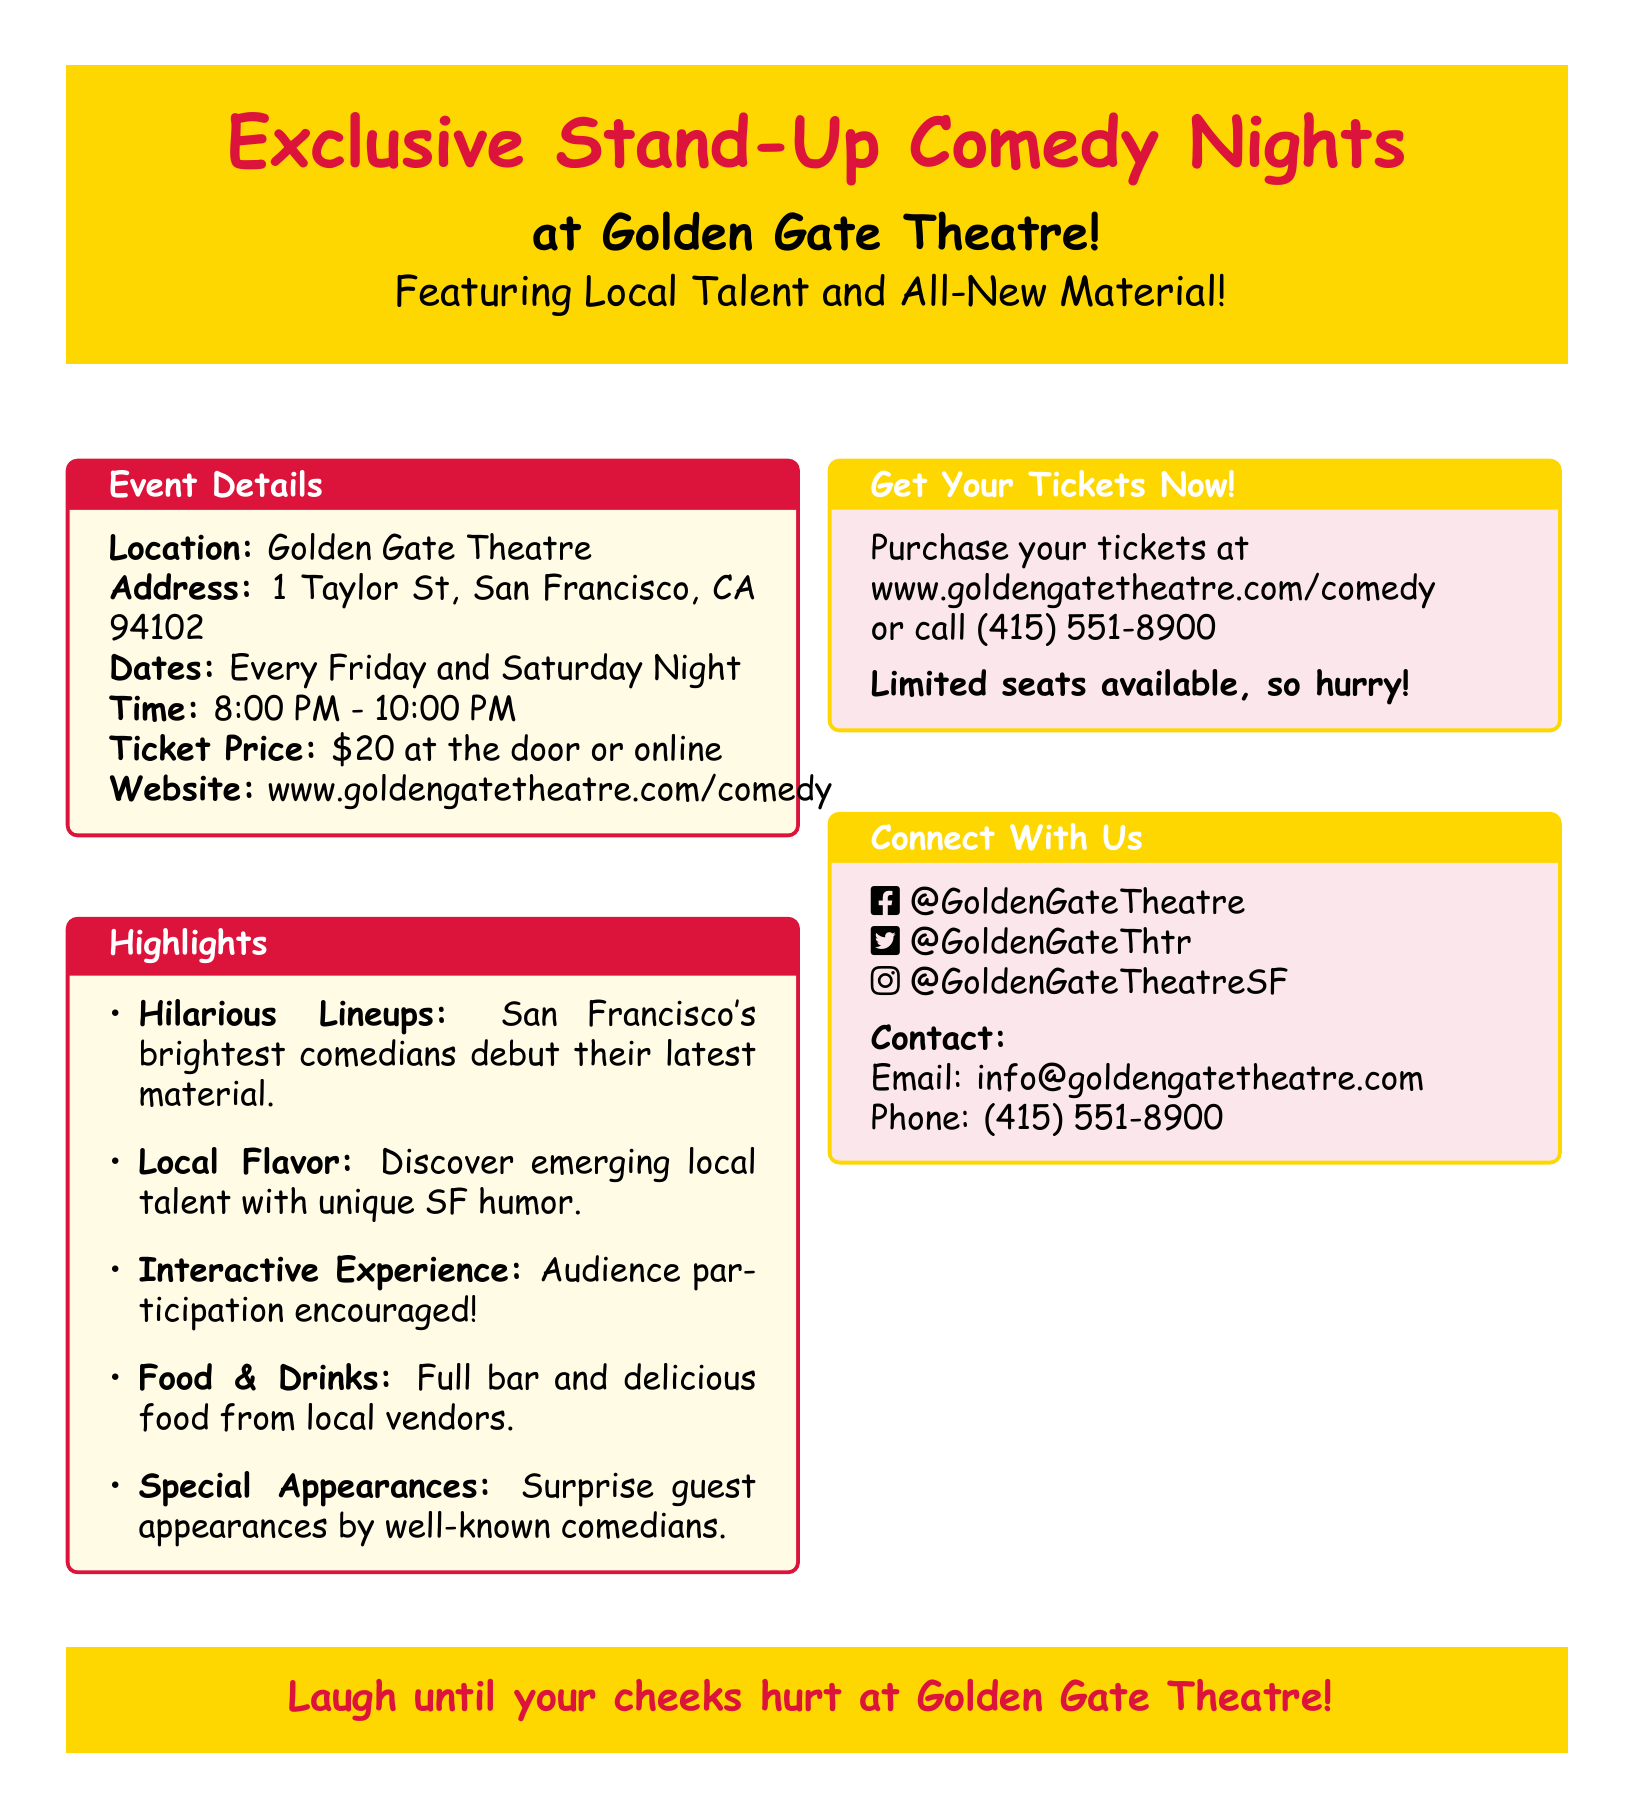What is the location of the event? The event is taking place at the Golden Gate Theatre, as mentioned in the document.
Answer: Golden Gate Theatre What are the ticket prices? The ticket prices are specified in the document as either at the door or online.
Answer: $20 On which days is the comedy night held? The document states that the comedy nights occur on specific days of the week.
Answer: Every Friday and Saturday Night What time does the event start? The document provides the start time for the event, which is crucial for attendees.
Answer: 8:00 PM What can attendees expect from the lineups? The document mentions the type of comedians and their material to be featured at the event.
Answer: Latest material What type of atmosphere is encouraged in the event? The document highlights audience interaction as a key part of the experience during the shows.
Answer: Audience participation What is offered in addition to comedy? The document lists additional features that enhance the experience during the comedy nights.
Answer: Food & Drinks How can tickets be purchased? The document provides information on where attendees can buy tickets for the event.
Answer: www.goldengatetheatre.com/comedy What is the contact number for inquiries? The document includes a specific phone number for people to call for more information.
Answer: (415) 551-8900 